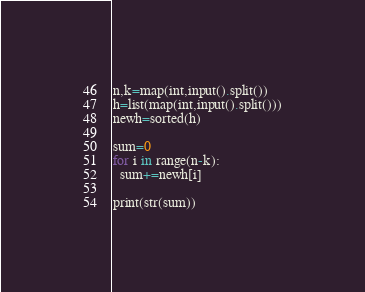<code> <loc_0><loc_0><loc_500><loc_500><_Python_>n,k=map(int,input().split())
h=list(map(int,input().split()))
newh=sorted(h)

sum=0
for i in range(n-k):
  sum+=newh[i]

print(str(sum))
</code> 